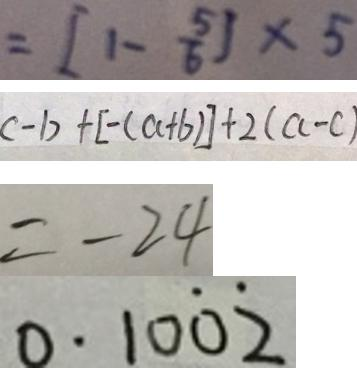Convert formula to latex. <formula><loc_0><loc_0><loc_500><loc_500>= [ 1 - \frac { 5 } { 6 } ] \times 5 
 c - b + [ - ( a + b ) ] + 2 ( a - c ) 
 = - 2 4 
 0 . 1 0 \dot { 0 } \dot { 2 }</formula> 